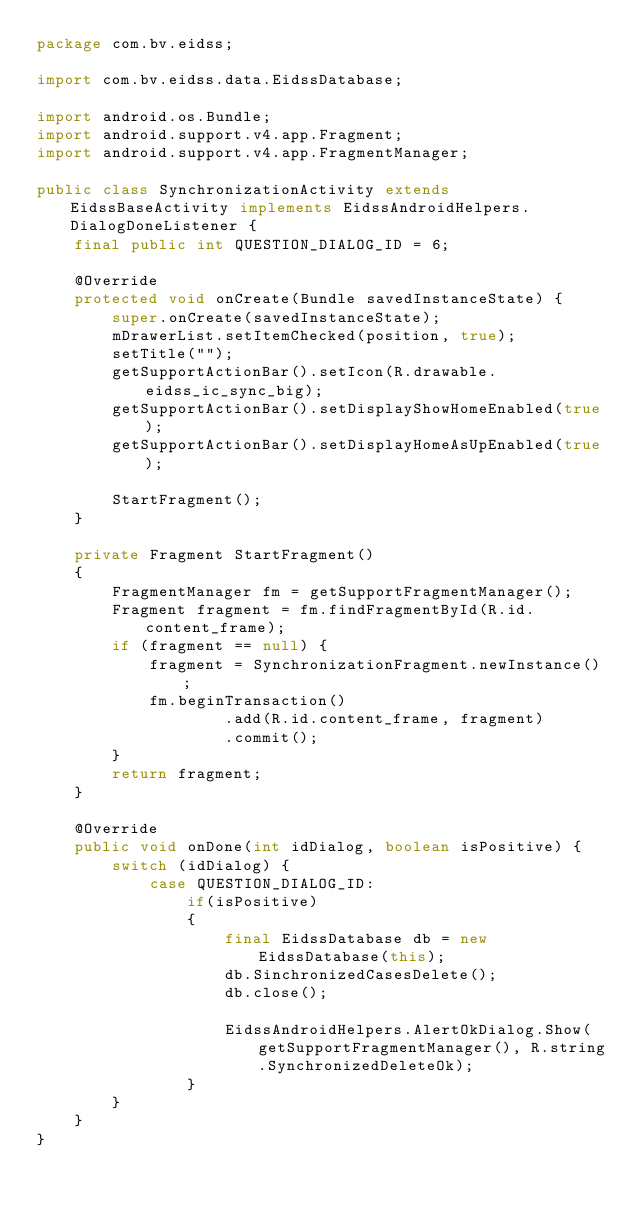Convert code to text. <code><loc_0><loc_0><loc_500><loc_500><_Java_>package com.bv.eidss;

import com.bv.eidss.data.EidssDatabase;

import android.os.Bundle;
import android.support.v4.app.Fragment;
import android.support.v4.app.FragmentManager;

public class SynchronizationActivity extends EidssBaseActivity implements EidssAndroidHelpers.DialogDoneListener {
    final public int QUESTION_DIALOG_ID = 6;

    @Override
    protected void onCreate(Bundle savedInstanceState) {
        super.onCreate(savedInstanceState);
        mDrawerList.setItemChecked(position, true);
        setTitle("");
        getSupportActionBar().setIcon(R.drawable.eidss_ic_sync_big);
        getSupportActionBar().setDisplayShowHomeEnabled(true);
        getSupportActionBar().setDisplayHomeAsUpEnabled(true);

        StartFragment();
    }

    private Fragment StartFragment()
    {
        FragmentManager fm = getSupportFragmentManager();
        Fragment fragment = fm.findFragmentById(R.id.content_frame);
        if (fragment == null) {
            fragment = SynchronizationFragment.newInstance();
            fm.beginTransaction()
                    .add(R.id.content_frame, fragment)
                    .commit();
        }
        return fragment;
    }

    @Override
    public void onDone(int idDialog, boolean isPositive) {
        switch (idDialog) {
            case QUESTION_DIALOG_ID:
                if(isPositive)
                {
                    final EidssDatabase db = new EidssDatabase(this);
                    db.SinchronizedCasesDelete();
                    db.close();

                    EidssAndroidHelpers.AlertOkDialog.Show(getSupportFragmentManager(), R.string.SynchronizedDeleteOk);
                }
        }
    }
}

</code> 